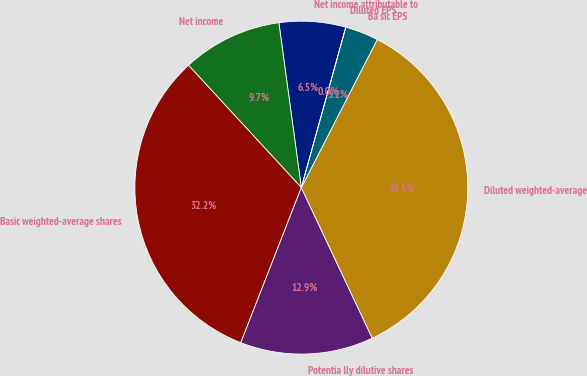Convert chart to OTSL. <chart><loc_0><loc_0><loc_500><loc_500><pie_chart><fcel>Net income attributable to<fcel>Net income<fcel>Basic weighted-average shares<fcel>Potentia lly dilutive shares<fcel>Diluted weighted-average<fcel>Ba sic EPS<fcel>Diluted EPS<nl><fcel>6.46%<fcel>9.7%<fcel>32.22%<fcel>12.93%<fcel>35.45%<fcel>3.23%<fcel>0.0%<nl></chart> 